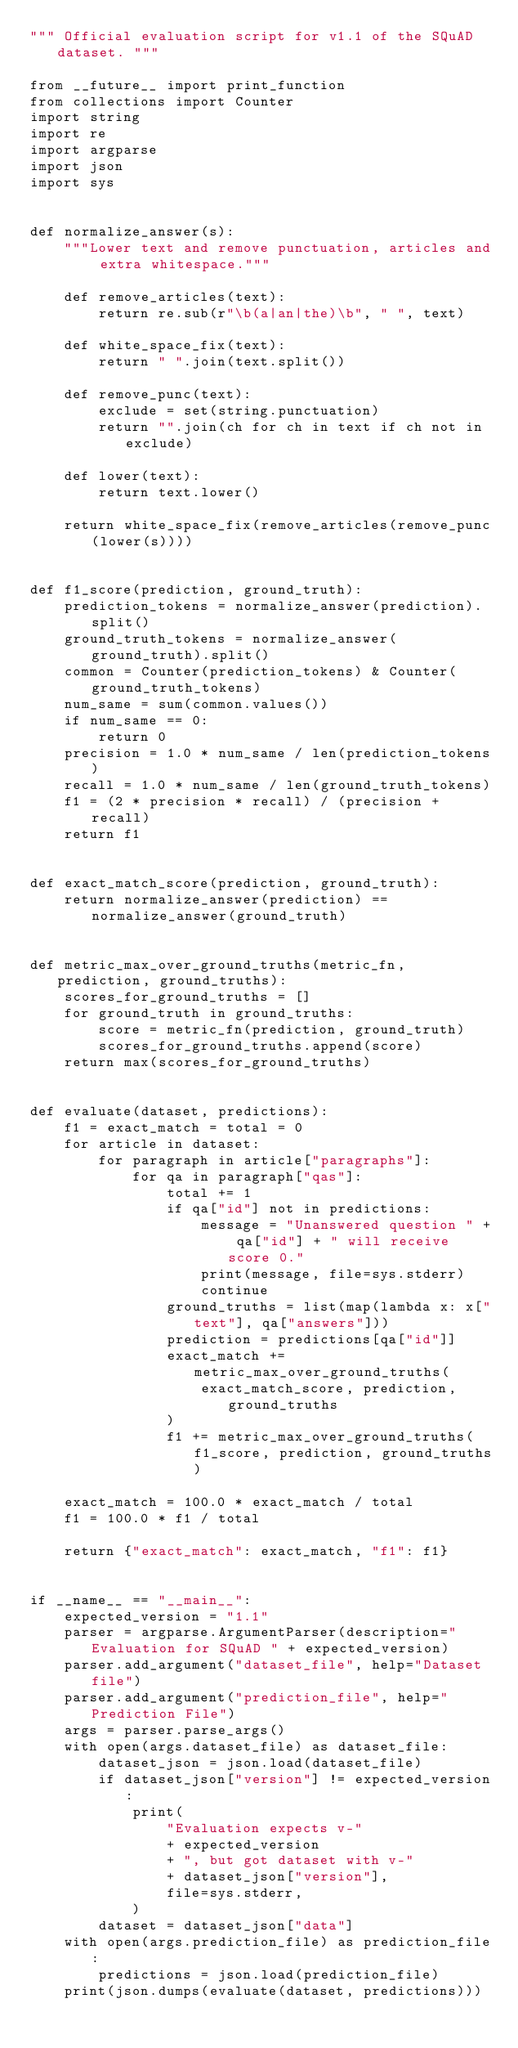Convert code to text. <code><loc_0><loc_0><loc_500><loc_500><_Python_>""" Official evaluation script for v1.1 of the SQuAD dataset. """

from __future__ import print_function
from collections import Counter
import string
import re
import argparse
import json
import sys


def normalize_answer(s):
    """Lower text and remove punctuation, articles and extra whitespace."""

    def remove_articles(text):
        return re.sub(r"\b(a|an|the)\b", " ", text)

    def white_space_fix(text):
        return " ".join(text.split())

    def remove_punc(text):
        exclude = set(string.punctuation)
        return "".join(ch for ch in text if ch not in exclude)

    def lower(text):
        return text.lower()

    return white_space_fix(remove_articles(remove_punc(lower(s))))


def f1_score(prediction, ground_truth):
    prediction_tokens = normalize_answer(prediction).split()
    ground_truth_tokens = normalize_answer(ground_truth).split()
    common = Counter(prediction_tokens) & Counter(ground_truth_tokens)
    num_same = sum(common.values())
    if num_same == 0:
        return 0
    precision = 1.0 * num_same / len(prediction_tokens)
    recall = 1.0 * num_same / len(ground_truth_tokens)
    f1 = (2 * precision * recall) / (precision + recall)
    return f1


def exact_match_score(prediction, ground_truth):
    return normalize_answer(prediction) == normalize_answer(ground_truth)


def metric_max_over_ground_truths(metric_fn, prediction, ground_truths):
    scores_for_ground_truths = []
    for ground_truth in ground_truths:
        score = metric_fn(prediction, ground_truth)
        scores_for_ground_truths.append(score)
    return max(scores_for_ground_truths)


def evaluate(dataset, predictions):
    f1 = exact_match = total = 0
    for article in dataset:
        for paragraph in article["paragraphs"]:
            for qa in paragraph["qas"]:
                total += 1
                if qa["id"] not in predictions:
                    message = "Unanswered question " + qa["id"] + " will receive score 0."
                    print(message, file=sys.stderr)
                    continue
                ground_truths = list(map(lambda x: x["text"], qa["answers"]))
                prediction = predictions[qa["id"]]
                exact_match += metric_max_over_ground_truths(
                    exact_match_score, prediction, ground_truths
                )
                f1 += metric_max_over_ground_truths(f1_score, prediction, ground_truths)

    exact_match = 100.0 * exact_match / total
    f1 = 100.0 * f1 / total

    return {"exact_match": exact_match, "f1": f1}


if __name__ == "__main__":
    expected_version = "1.1"
    parser = argparse.ArgumentParser(description="Evaluation for SQuAD " + expected_version)
    parser.add_argument("dataset_file", help="Dataset file")
    parser.add_argument("prediction_file", help="Prediction File")
    args = parser.parse_args()
    with open(args.dataset_file) as dataset_file:
        dataset_json = json.load(dataset_file)
        if dataset_json["version"] != expected_version:
            print(
                "Evaluation expects v-"
                + expected_version
                + ", but got dataset with v-"
                + dataset_json["version"],
                file=sys.stderr,
            )
        dataset = dataset_json["data"]
    with open(args.prediction_file) as prediction_file:
        predictions = json.load(prediction_file)
    print(json.dumps(evaluate(dataset, predictions)))
</code> 